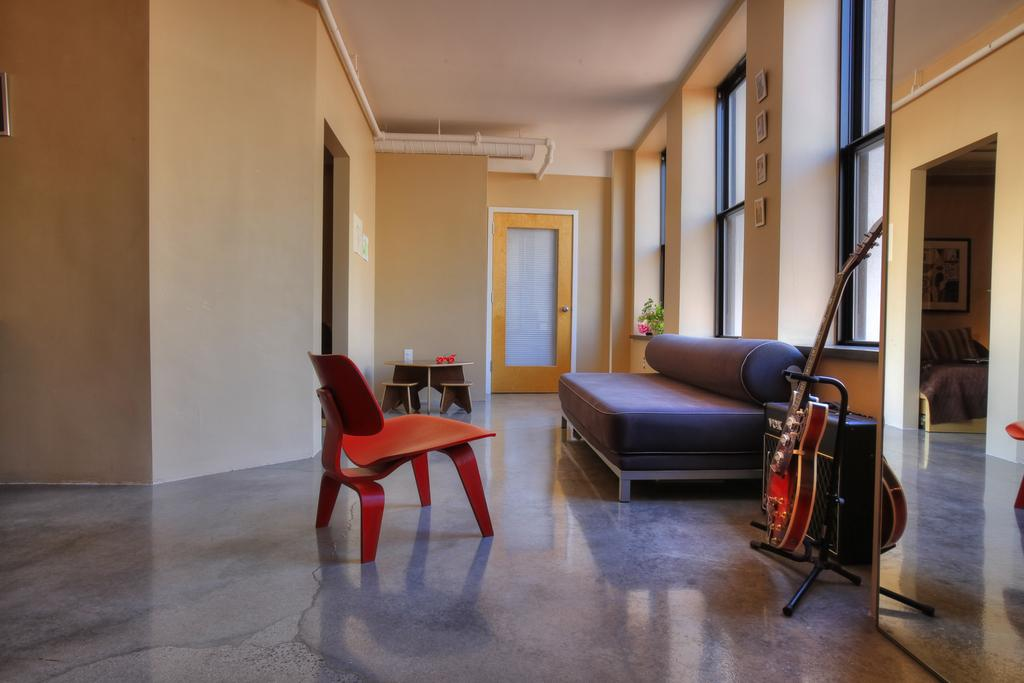What type of furniture is present in the room? There is a diwan cot, a table with a chair, and a guitar in the room. What can be seen in the background of the room? There is a door, a wall, and windows in the background of the room. What type of account is being discussed in the room? There is no mention of an account or any financial discussion in the image. 